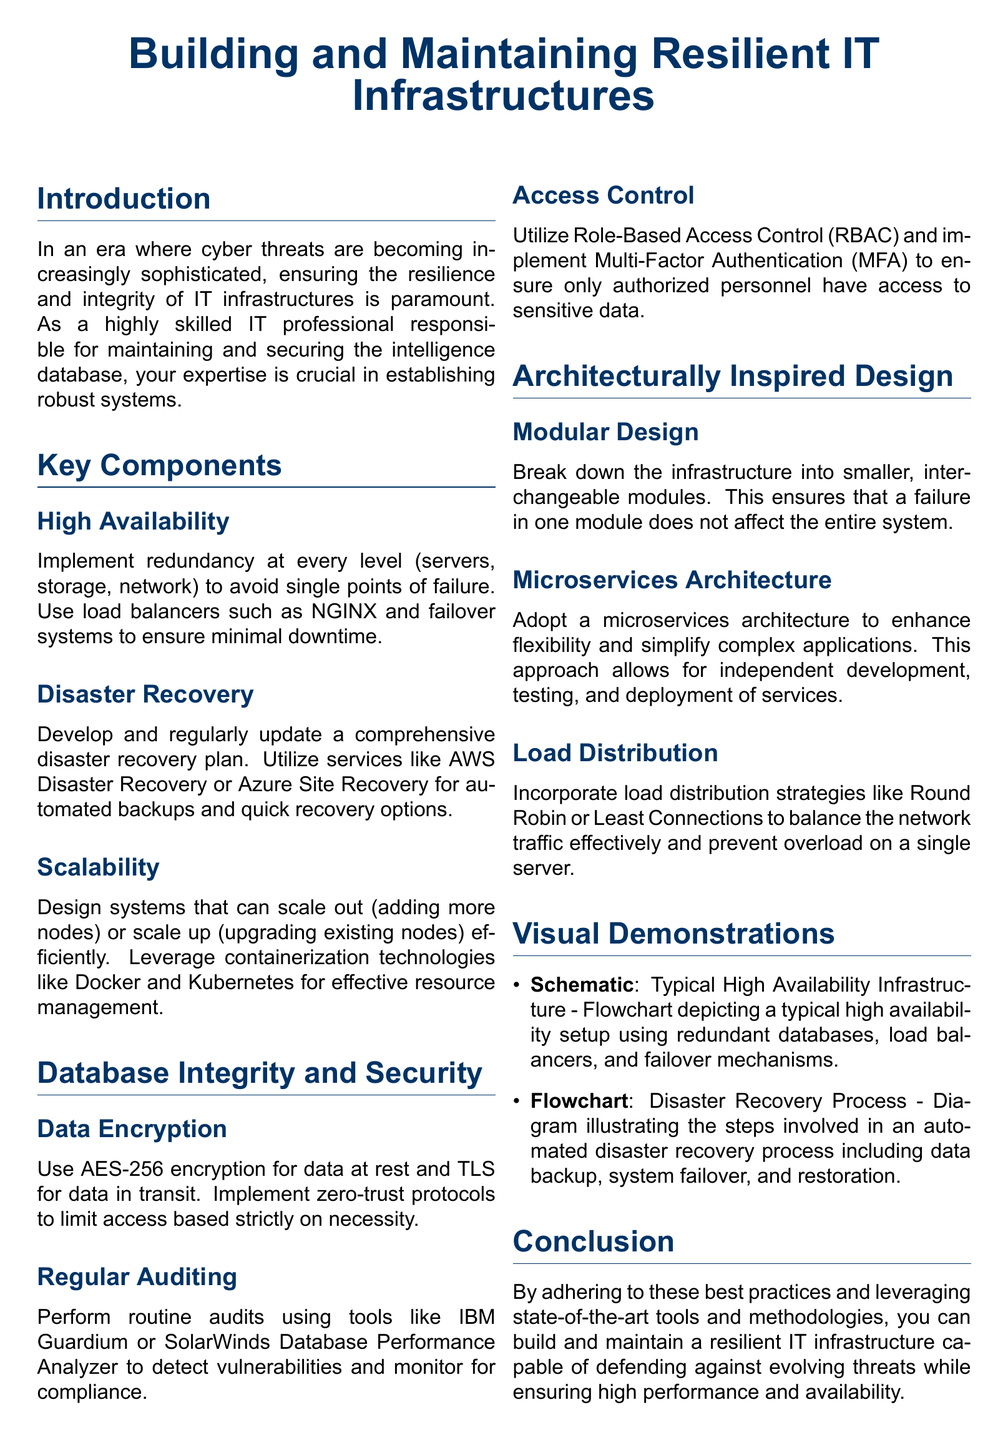What is the main focus of the document? The introduction section states that the document focuses on ensuring the resilience and integrity of IT infrastructures in the face of cyber threats.
Answer: Resilience and integrity What methodology does the document suggest for achieving high availability? In the Key Components section, it mentions implementing redundancy at every level to avoid single points of failure.
Answer: Redundancy What encryption standard is recommended for data at rest? The Database Integrity and Security section specifies using AES-256 encryption for data at rest.
Answer: AES-256 What is a key feature of Modular Design according to the document? The section on Architecturally Inspired Design describes Modular Design as having smaller, interchangeable modules to prevent total system failure.
Answer: Interchangeable modules What role do load balancers play in maintaining IT infrastructure? The use of load balancers is mentioned in the context of ensuring minimal downtime, highlighting their importance in high availability setups.
Answer: Minimal downtime Which technology is suggested for resource management in scalability? The document advocates leveraging containerization technologies like Docker and Kubernetes for effective resource management.
Answer: Docker and Kubernetes What auditing tools are mentioned in the context of security? The document lists IBM Guardium and SolarWinds Database Performance Analyzer as tools for performing routine audits related to security.
Answer: IBM Guardium, SolarWinds What architectural pattern is recommended to enhance flexibility? The document mentions adopting a microservices architecture as a recommended practice to enhance flexibility within the IT infrastructure.
Answer: Microservices architecture What visual elements are included in the document? The Visual Demonstrations section lists a schematic for High Availability Infrastructure and a flowchart for the Disaster Recovery Process.
Answer: Schematic, flowchart 